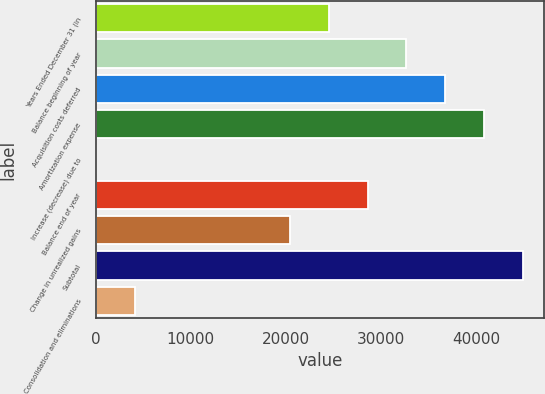<chart> <loc_0><loc_0><loc_500><loc_500><bar_chart><fcel>Years Ended December 31 (in<fcel>Balance beginning of year<fcel>Acquisition costs deferred<fcel>Amortization expense<fcel>Increase (decrease) due to<fcel>Balance end of year<fcel>Change in unrealized gains<fcel>Subtotal<fcel>Consolidation and eliminations<nl><fcel>24492.4<fcel>32653.2<fcel>36733.6<fcel>40814<fcel>10<fcel>28572.8<fcel>20412<fcel>44894.4<fcel>4090.4<nl></chart> 